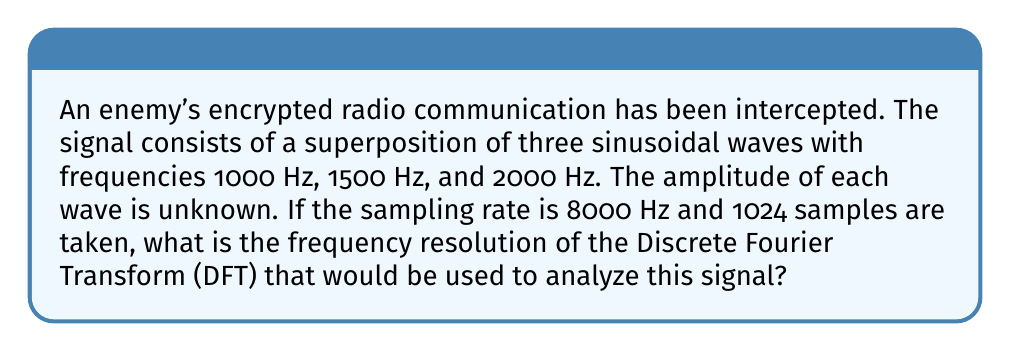Could you help me with this problem? To solve this problem, we need to understand the relationship between the sampling rate, number of samples, and frequency resolution in the Discrete Fourier Transform (DFT).

1. The frequency resolution (Δf) of a DFT is given by the formula:

   $$\Delta f = \frac{f_s}{N}$$

   Where:
   $f_s$ is the sampling rate
   $N$ is the number of samples

2. We are given:
   $f_s = 8000$ Hz
   $N = 1024$ samples

3. Substituting these values into the formula:

   $$\Delta f = \frac{8000\text{ Hz}}{1024}$$

4. Simplifying:

   $$\Delta f = 7.8125\text{ Hz}$$

This frequency resolution means that the DFT will be able to distinguish between frequency components that are at least 7.8125 Hz apart. This resolution is sufficient to distinguish between the three given frequencies (1000 Hz, 1500 Hz, and 2000 Hz) in the intercepted signal.

For a military commander, this information is crucial as it determines the precision with which the frequencies in the encrypted communication can be identified. A higher resolution (smaller Δf) would allow for more accurate frequency identification, potentially leading to better decryption of the enemy's communication.
Answer: $$\Delta f = 7.8125\text{ Hz}$$ 